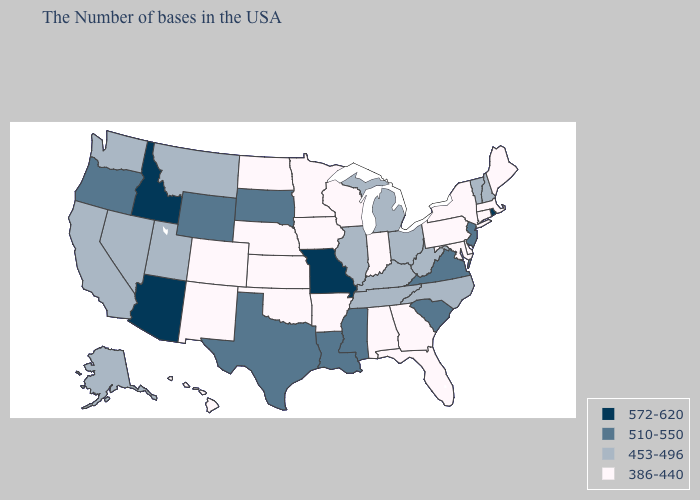Name the states that have a value in the range 572-620?
Concise answer only. Rhode Island, Missouri, Arizona, Idaho. Does Oregon have the highest value in the West?
Be succinct. No. Which states hav the highest value in the Northeast?
Answer briefly. Rhode Island. Which states have the lowest value in the USA?
Give a very brief answer. Maine, Massachusetts, Connecticut, New York, Delaware, Maryland, Pennsylvania, Florida, Georgia, Indiana, Alabama, Wisconsin, Arkansas, Minnesota, Iowa, Kansas, Nebraska, Oklahoma, North Dakota, Colorado, New Mexico, Hawaii. What is the value of Rhode Island?
Give a very brief answer. 572-620. Which states hav the highest value in the South?
Answer briefly. Virginia, South Carolina, Mississippi, Louisiana, Texas. Name the states that have a value in the range 386-440?
Quick response, please. Maine, Massachusetts, Connecticut, New York, Delaware, Maryland, Pennsylvania, Florida, Georgia, Indiana, Alabama, Wisconsin, Arkansas, Minnesota, Iowa, Kansas, Nebraska, Oklahoma, North Dakota, Colorado, New Mexico, Hawaii. Which states hav the highest value in the MidWest?
Concise answer only. Missouri. Does Arkansas have a lower value than Oklahoma?
Quick response, please. No. Name the states that have a value in the range 510-550?
Concise answer only. New Jersey, Virginia, South Carolina, Mississippi, Louisiana, Texas, South Dakota, Wyoming, Oregon. Name the states that have a value in the range 453-496?
Give a very brief answer. New Hampshire, Vermont, North Carolina, West Virginia, Ohio, Michigan, Kentucky, Tennessee, Illinois, Utah, Montana, Nevada, California, Washington, Alaska. Name the states that have a value in the range 510-550?
Short answer required. New Jersey, Virginia, South Carolina, Mississippi, Louisiana, Texas, South Dakota, Wyoming, Oregon. How many symbols are there in the legend?
Write a very short answer. 4. Which states have the highest value in the USA?
Keep it brief. Rhode Island, Missouri, Arizona, Idaho. What is the value of Pennsylvania?
Answer briefly. 386-440. 